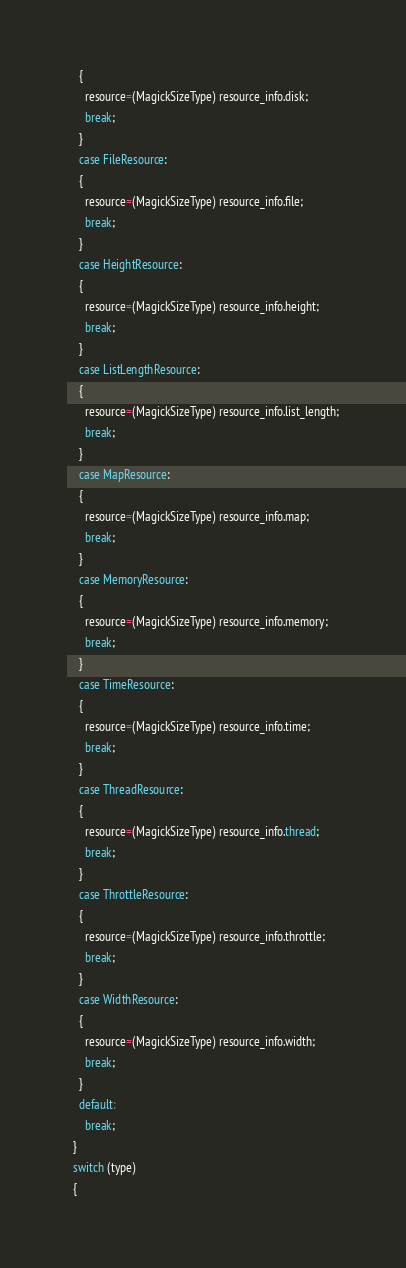<code> <loc_0><loc_0><loc_500><loc_500><_C_>    {
      resource=(MagickSizeType) resource_info.disk;
      break;
    }
    case FileResource:
    {
      resource=(MagickSizeType) resource_info.file;
      break;
    }
    case HeightResource:
    {
      resource=(MagickSizeType) resource_info.height;
      break;
    }
    case ListLengthResource:
    {
      resource=(MagickSizeType) resource_info.list_length;
      break;
    }
    case MapResource:
    {
      resource=(MagickSizeType) resource_info.map;
      break;
    }
    case MemoryResource:
    {
      resource=(MagickSizeType) resource_info.memory;
      break;
    }
    case TimeResource:
    {
      resource=(MagickSizeType) resource_info.time;
      break;
    }
    case ThreadResource:
    {
      resource=(MagickSizeType) resource_info.thread;
      break;
    }
    case ThrottleResource:
    {
      resource=(MagickSizeType) resource_info.throttle;
      break;
    }
    case WidthResource:
    {
      resource=(MagickSizeType) resource_info.width;
      break;
    }
    default:
      break;
  }
  switch (type)
  {</code> 